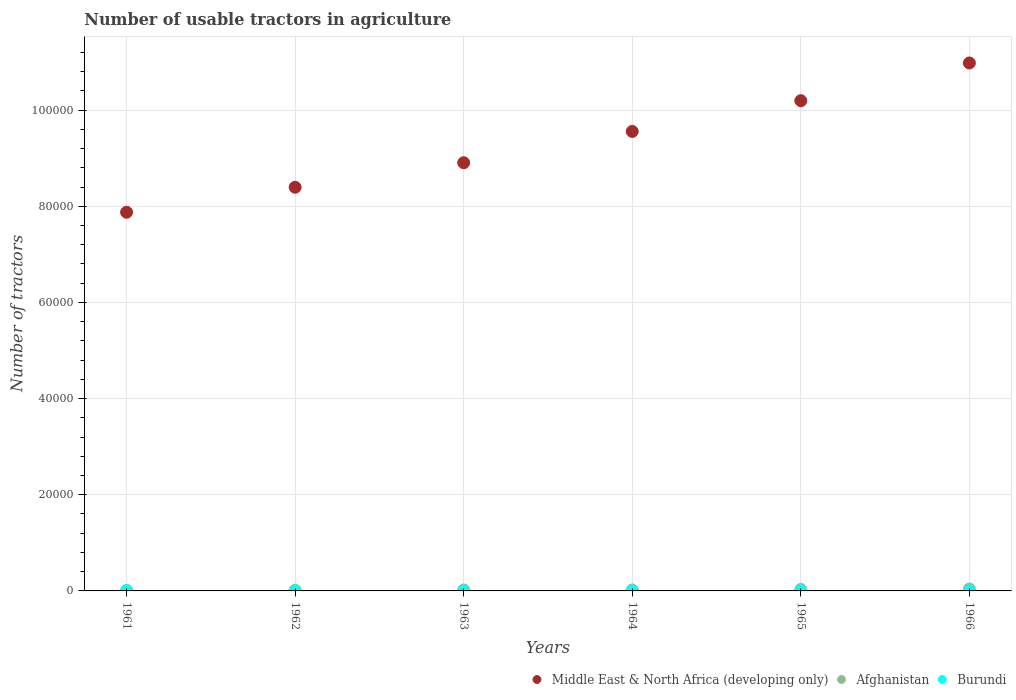What is the number of usable tractors in agriculture in Burundi in 1966?
Provide a succinct answer. 2. Across all years, what is the maximum number of usable tractors in agriculture in Burundi?
Your response must be concise. 2. Across all years, what is the minimum number of usable tractors in agriculture in Afghanistan?
Provide a short and direct response. 120. In which year was the number of usable tractors in agriculture in Burundi maximum?
Provide a short and direct response. 1961. In which year was the number of usable tractors in agriculture in Middle East & North Africa (developing only) minimum?
Your answer should be very brief. 1961. What is the total number of usable tractors in agriculture in Afghanistan in the graph?
Provide a succinct answer. 1370. What is the difference between the number of usable tractors in agriculture in Afghanistan in 1961 and that in 1966?
Provide a short and direct response. -280. What is the difference between the number of usable tractors in agriculture in Burundi in 1961 and the number of usable tractors in agriculture in Afghanistan in 1963?
Keep it short and to the point. -198. What is the average number of usable tractors in agriculture in Afghanistan per year?
Offer a very short reply. 228.33. In the year 1963, what is the difference between the number of usable tractors in agriculture in Middle East & North Africa (developing only) and number of usable tractors in agriculture in Burundi?
Make the answer very short. 8.91e+04. In how many years, is the number of usable tractors in agriculture in Middle East & North Africa (developing only) greater than 88000?
Give a very brief answer. 4. What is the ratio of the number of usable tractors in agriculture in Middle East & North Africa (developing only) in 1961 to that in 1962?
Your answer should be very brief. 0.94. What is the difference between the highest and the lowest number of usable tractors in agriculture in Afghanistan?
Give a very brief answer. 280. Is it the case that in every year, the sum of the number of usable tractors in agriculture in Afghanistan and number of usable tractors in agriculture in Burundi  is greater than the number of usable tractors in agriculture in Middle East & North Africa (developing only)?
Provide a succinct answer. No. Does the graph contain any zero values?
Your answer should be compact. No. Where does the legend appear in the graph?
Make the answer very short. Bottom right. How many legend labels are there?
Ensure brevity in your answer.  3. What is the title of the graph?
Offer a terse response. Number of usable tractors in agriculture. What is the label or title of the X-axis?
Keep it short and to the point. Years. What is the label or title of the Y-axis?
Provide a succinct answer. Number of tractors. What is the Number of tractors of Middle East & North Africa (developing only) in 1961?
Your answer should be very brief. 7.88e+04. What is the Number of tractors in Afghanistan in 1961?
Ensure brevity in your answer.  120. What is the Number of tractors of Middle East & North Africa (developing only) in 1962?
Your answer should be compact. 8.40e+04. What is the Number of tractors of Afghanistan in 1962?
Provide a short and direct response. 150. What is the Number of tractors in Middle East & North Africa (developing only) in 1963?
Keep it short and to the point. 8.91e+04. What is the Number of tractors in Afghanistan in 1963?
Your answer should be very brief. 200. What is the Number of tractors of Middle East & North Africa (developing only) in 1964?
Make the answer very short. 9.56e+04. What is the Number of tractors in Afghanistan in 1964?
Provide a short and direct response. 200. What is the Number of tractors of Middle East & North Africa (developing only) in 1965?
Provide a short and direct response. 1.02e+05. What is the Number of tractors of Afghanistan in 1965?
Provide a short and direct response. 300. What is the Number of tractors in Middle East & North Africa (developing only) in 1966?
Offer a terse response. 1.10e+05. What is the Number of tractors in Afghanistan in 1966?
Provide a short and direct response. 400. What is the Number of tractors in Burundi in 1966?
Offer a terse response. 2. Across all years, what is the maximum Number of tractors of Middle East & North Africa (developing only)?
Provide a short and direct response. 1.10e+05. Across all years, what is the maximum Number of tractors of Afghanistan?
Offer a very short reply. 400. Across all years, what is the minimum Number of tractors in Middle East & North Africa (developing only)?
Provide a succinct answer. 7.88e+04. Across all years, what is the minimum Number of tractors in Afghanistan?
Provide a short and direct response. 120. What is the total Number of tractors in Middle East & North Africa (developing only) in the graph?
Your response must be concise. 5.59e+05. What is the total Number of tractors of Afghanistan in the graph?
Provide a succinct answer. 1370. What is the difference between the Number of tractors of Middle East & North Africa (developing only) in 1961 and that in 1962?
Provide a short and direct response. -5192. What is the difference between the Number of tractors of Afghanistan in 1961 and that in 1962?
Your response must be concise. -30. What is the difference between the Number of tractors of Middle East & North Africa (developing only) in 1961 and that in 1963?
Provide a short and direct response. -1.03e+04. What is the difference between the Number of tractors in Afghanistan in 1961 and that in 1963?
Give a very brief answer. -80. What is the difference between the Number of tractors of Middle East & North Africa (developing only) in 1961 and that in 1964?
Your response must be concise. -1.68e+04. What is the difference between the Number of tractors of Afghanistan in 1961 and that in 1964?
Offer a terse response. -80. What is the difference between the Number of tractors in Burundi in 1961 and that in 1964?
Offer a terse response. 0. What is the difference between the Number of tractors in Middle East & North Africa (developing only) in 1961 and that in 1965?
Offer a very short reply. -2.32e+04. What is the difference between the Number of tractors in Afghanistan in 1961 and that in 1965?
Make the answer very short. -180. What is the difference between the Number of tractors in Burundi in 1961 and that in 1965?
Give a very brief answer. 0. What is the difference between the Number of tractors in Middle East & North Africa (developing only) in 1961 and that in 1966?
Provide a short and direct response. -3.10e+04. What is the difference between the Number of tractors of Afghanistan in 1961 and that in 1966?
Offer a terse response. -280. What is the difference between the Number of tractors in Middle East & North Africa (developing only) in 1962 and that in 1963?
Provide a short and direct response. -5107. What is the difference between the Number of tractors of Middle East & North Africa (developing only) in 1962 and that in 1964?
Your answer should be very brief. -1.16e+04. What is the difference between the Number of tractors of Afghanistan in 1962 and that in 1964?
Make the answer very short. -50. What is the difference between the Number of tractors in Middle East & North Africa (developing only) in 1962 and that in 1965?
Your response must be concise. -1.80e+04. What is the difference between the Number of tractors in Afghanistan in 1962 and that in 1965?
Your answer should be very brief. -150. What is the difference between the Number of tractors in Burundi in 1962 and that in 1965?
Offer a very short reply. 0. What is the difference between the Number of tractors in Middle East & North Africa (developing only) in 1962 and that in 1966?
Your response must be concise. -2.59e+04. What is the difference between the Number of tractors in Afghanistan in 1962 and that in 1966?
Give a very brief answer. -250. What is the difference between the Number of tractors of Burundi in 1962 and that in 1966?
Keep it short and to the point. 0. What is the difference between the Number of tractors of Middle East & North Africa (developing only) in 1963 and that in 1964?
Offer a terse response. -6506. What is the difference between the Number of tractors in Burundi in 1963 and that in 1964?
Provide a short and direct response. 0. What is the difference between the Number of tractors of Middle East & North Africa (developing only) in 1963 and that in 1965?
Keep it short and to the point. -1.29e+04. What is the difference between the Number of tractors of Afghanistan in 1963 and that in 1965?
Your answer should be compact. -100. What is the difference between the Number of tractors of Burundi in 1963 and that in 1965?
Your answer should be very brief. 0. What is the difference between the Number of tractors in Middle East & North Africa (developing only) in 1963 and that in 1966?
Your answer should be compact. -2.07e+04. What is the difference between the Number of tractors of Afghanistan in 1963 and that in 1966?
Your answer should be very brief. -200. What is the difference between the Number of tractors of Burundi in 1963 and that in 1966?
Your answer should be compact. 0. What is the difference between the Number of tractors in Middle East & North Africa (developing only) in 1964 and that in 1965?
Your answer should be compact. -6395. What is the difference between the Number of tractors in Afghanistan in 1964 and that in 1965?
Offer a terse response. -100. What is the difference between the Number of tractors in Middle East & North Africa (developing only) in 1964 and that in 1966?
Your answer should be compact. -1.42e+04. What is the difference between the Number of tractors of Afghanistan in 1964 and that in 1966?
Offer a terse response. -200. What is the difference between the Number of tractors in Middle East & North Africa (developing only) in 1965 and that in 1966?
Keep it short and to the point. -7846. What is the difference between the Number of tractors in Afghanistan in 1965 and that in 1966?
Your answer should be very brief. -100. What is the difference between the Number of tractors of Middle East & North Africa (developing only) in 1961 and the Number of tractors of Afghanistan in 1962?
Provide a short and direct response. 7.86e+04. What is the difference between the Number of tractors of Middle East & North Africa (developing only) in 1961 and the Number of tractors of Burundi in 1962?
Your answer should be very brief. 7.88e+04. What is the difference between the Number of tractors in Afghanistan in 1961 and the Number of tractors in Burundi in 1962?
Your answer should be very brief. 118. What is the difference between the Number of tractors in Middle East & North Africa (developing only) in 1961 and the Number of tractors in Afghanistan in 1963?
Make the answer very short. 7.86e+04. What is the difference between the Number of tractors of Middle East & North Africa (developing only) in 1961 and the Number of tractors of Burundi in 1963?
Offer a terse response. 7.88e+04. What is the difference between the Number of tractors of Afghanistan in 1961 and the Number of tractors of Burundi in 1963?
Ensure brevity in your answer.  118. What is the difference between the Number of tractors in Middle East & North Africa (developing only) in 1961 and the Number of tractors in Afghanistan in 1964?
Offer a very short reply. 7.86e+04. What is the difference between the Number of tractors in Middle East & North Africa (developing only) in 1961 and the Number of tractors in Burundi in 1964?
Make the answer very short. 7.88e+04. What is the difference between the Number of tractors in Afghanistan in 1961 and the Number of tractors in Burundi in 1964?
Offer a very short reply. 118. What is the difference between the Number of tractors in Middle East & North Africa (developing only) in 1961 and the Number of tractors in Afghanistan in 1965?
Ensure brevity in your answer.  7.85e+04. What is the difference between the Number of tractors in Middle East & North Africa (developing only) in 1961 and the Number of tractors in Burundi in 1965?
Provide a short and direct response. 7.88e+04. What is the difference between the Number of tractors in Afghanistan in 1961 and the Number of tractors in Burundi in 1965?
Give a very brief answer. 118. What is the difference between the Number of tractors in Middle East & North Africa (developing only) in 1961 and the Number of tractors in Afghanistan in 1966?
Keep it short and to the point. 7.84e+04. What is the difference between the Number of tractors in Middle East & North Africa (developing only) in 1961 and the Number of tractors in Burundi in 1966?
Provide a succinct answer. 7.88e+04. What is the difference between the Number of tractors in Afghanistan in 1961 and the Number of tractors in Burundi in 1966?
Provide a succinct answer. 118. What is the difference between the Number of tractors in Middle East & North Africa (developing only) in 1962 and the Number of tractors in Afghanistan in 1963?
Offer a very short reply. 8.38e+04. What is the difference between the Number of tractors in Middle East & North Africa (developing only) in 1962 and the Number of tractors in Burundi in 1963?
Your answer should be compact. 8.39e+04. What is the difference between the Number of tractors of Afghanistan in 1962 and the Number of tractors of Burundi in 1963?
Your response must be concise. 148. What is the difference between the Number of tractors in Middle East & North Africa (developing only) in 1962 and the Number of tractors in Afghanistan in 1964?
Offer a very short reply. 8.38e+04. What is the difference between the Number of tractors in Middle East & North Africa (developing only) in 1962 and the Number of tractors in Burundi in 1964?
Your answer should be compact. 8.39e+04. What is the difference between the Number of tractors in Afghanistan in 1962 and the Number of tractors in Burundi in 1964?
Give a very brief answer. 148. What is the difference between the Number of tractors in Middle East & North Africa (developing only) in 1962 and the Number of tractors in Afghanistan in 1965?
Ensure brevity in your answer.  8.36e+04. What is the difference between the Number of tractors in Middle East & North Africa (developing only) in 1962 and the Number of tractors in Burundi in 1965?
Your response must be concise. 8.39e+04. What is the difference between the Number of tractors in Afghanistan in 1962 and the Number of tractors in Burundi in 1965?
Provide a short and direct response. 148. What is the difference between the Number of tractors in Middle East & North Africa (developing only) in 1962 and the Number of tractors in Afghanistan in 1966?
Keep it short and to the point. 8.36e+04. What is the difference between the Number of tractors of Middle East & North Africa (developing only) in 1962 and the Number of tractors of Burundi in 1966?
Offer a terse response. 8.39e+04. What is the difference between the Number of tractors in Afghanistan in 1962 and the Number of tractors in Burundi in 1966?
Make the answer very short. 148. What is the difference between the Number of tractors of Middle East & North Africa (developing only) in 1963 and the Number of tractors of Afghanistan in 1964?
Give a very brief answer. 8.89e+04. What is the difference between the Number of tractors in Middle East & North Africa (developing only) in 1963 and the Number of tractors in Burundi in 1964?
Ensure brevity in your answer.  8.91e+04. What is the difference between the Number of tractors of Afghanistan in 1963 and the Number of tractors of Burundi in 1964?
Your answer should be very brief. 198. What is the difference between the Number of tractors in Middle East & North Africa (developing only) in 1963 and the Number of tractors in Afghanistan in 1965?
Your answer should be compact. 8.88e+04. What is the difference between the Number of tractors in Middle East & North Africa (developing only) in 1963 and the Number of tractors in Burundi in 1965?
Provide a short and direct response. 8.91e+04. What is the difference between the Number of tractors of Afghanistan in 1963 and the Number of tractors of Burundi in 1965?
Offer a terse response. 198. What is the difference between the Number of tractors of Middle East & North Africa (developing only) in 1963 and the Number of tractors of Afghanistan in 1966?
Make the answer very short. 8.87e+04. What is the difference between the Number of tractors of Middle East & North Africa (developing only) in 1963 and the Number of tractors of Burundi in 1966?
Your response must be concise. 8.91e+04. What is the difference between the Number of tractors in Afghanistan in 1963 and the Number of tractors in Burundi in 1966?
Provide a succinct answer. 198. What is the difference between the Number of tractors in Middle East & North Africa (developing only) in 1964 and the Number of tractors in Afghanistan in 1965?
Your answer should be very brief. 9.53e+04. What is the difference between the Number of tractors in Middle East & North Africa (developing only) in 1964 and the Number of tractors in Burundi in 1965?
Provide a short and direct response. 9.56e+04. What is the difference between the Number of tractors in Afghanistan in 1964 and the Number of tractors in Burundi in 1965?
Provide a succinct answer. 198. What is the difference between the Number of tractors in Middle East & North Africa (developing only) in 1964 and the Number of tractors in Afghanistan in 1966?
Provide a succinct answer. 9.52e+04. What is the difference between the Number of tractors in Middle East & North Africa (developing only) in 1964 and the Number of tractors in Burundi in 1966?
Offer a very short reply. 9.56e+04. What is the difference between the Number of tractors of Afghanistan in 1964 and the Number of tractors of Burundi in 1966?
Give a very brief answer. 198. What is the difference between the Number of tractors of Middle East & North Africa (developing only) in 1965 and the Number of tractors of Afghanistan in 1966?
Offer a very short reply. 1.02e+05. What is the difference between the Number of tractors in Middle East & North Africa (developing only) in 1965 and the Number of tractors in Burundi in 1966?
Provide a succinct answer. 1.02e+05. What is the difference between the Number of tractors of Afghanistan in 1965 and the Number of tractors of Burundi in 1966?
Provide a short and direct response. 298. What is the average Number of tractors of Middle East & North Africa (developing only) per year?
Ensure brevity in your answer.  9.32e+04. What is the average Number of tractors of Afghanistan per year?
Make the answer very short. 228.33. What is the average Number of tractors of Burundi per year?
Your answer should be compact. 2. In the year 1961, what is the difference between the Number of tractors of Middle East & North Africa (developing only) and Number of tractors of Afghanistan?
Provide a succinct answer. 7.86e+04. In the year 1961, what is the difference between the Number of tractors in Middle East & North Africa (developing only) and Number of tractors in Burundi?
Give a very brief answer. 7.88e+04. In the year 1961, what is the difference between the Number of tractors in Afghanistan and Number of tractors in Burundi?
Offer a very short reply. 118. In the year 1962, what is the difference between the Number of tractors of Middle East & North Africa (developing only) and Number of tractors of Afghanistan?
Make the answer very short. 8.38e+04. In the year 1962, what is the difference between the Number of tractors in Middle East & North Africa (developing only) and Number of tractors in Burundi?
Your answer should be very brief. 8.39e+04. In the year 1962, what is the difference between the Number of tractors in Afghanistan and Number of tractors in Burundi?
Make the answer very short. 148. In the year 1963, what is the difference between the Number of tractors of Middle East & North Africa (developing only) and Number of tractors of Afghanistan?
Provide a short and direct response. 8.89e+04. In the year 1963, what is the difference between the Number of tractors of Middle East & North Africa (developing only) and Number of tractors of Burundi?
Your answer should be very brief. 8.91e+04. In the year 1963, what is the difference between the Number of tractors in Afghanistan and Number of tractors in Burundi?
Offer a very short reply. 198. In the year 1964, what is the difference between the Number of tractors in Middle East & North Africa (developing only) and Number of tractors in Afghanistan?
Provide a succinct answer. 9.54e+04. In the year 1964, what is the difference between the Number of tractors in Middle East & North Africa (developing only) and Number of tractors in Burundi?
Your response must be concise. 9.56e+04. In the year 1964, what is the difference between the Number of tractors in Afghanistan and Number of tractors in Burundi?
Keep it short and to the point. 198. In the year 1965, what is the difference between the Number of tractors in Middle East & North Africa (developing only) and Number of tractors in Afghanistan?
Your answer should be very brief. 1.02e+05. In the year 1965, what is the difference between the Number of tractors in Middle East & North Africa (developing only) and Number of tractors in Burundi?
Your answer should be very brief. 1.02e+05. In the year 1965, what is the difference between the Number of tractors of Afghanistan and Number of tractors of Burundi?
Provide a succinct answer. 298. In the year 1966, what is the difference between the Number of tractors in Middle East & North Africa (developing only) and Number of tractors in Afghanistan?
Your answer should be compact. 1.09e+05. In the year 1966, what is the difference between the Number of tractors in Middle East & North Africa (developing only) and Number of tractors in Burundi?
Offer a terse response. 1.10e+05. In the year 1966, what is the difference between the Number of tractors of Afghanistan and Number of tractors of Burundi?
Make the answer very short. 398. What is the ratio of the Number of tractors of Middle East & North Africa (developing only) in 1961 to that in 1962?
Provide a short and direct response. 0.94. What is the ratio of the Number of tractors in Afghanistan in 1961 to that in 1962?
Provide a short and direct response. 0.8. What is the ratio of the Number of tractors of Middle East & North Africa (developing only) in 1961 to that in 1963?
Your answer should be compact. 0.88. What is the ratio of the Number of tractors in Burundi in 1961 to that in 1963?
Provide a succinct answer. 1. What is the ratio of the Number of tractors in Middle East & North Africa (developing only) in 1961 to that in 1964?
Give a very brief answer. 0.82. What is the ratio of the Number of tractors of Middle East & North Africa (developing only) in 1961 to that in 1965?
Make the answer very short. 0.77. What is the ratio of the Number of tractors in Afghanistan in 1961 to that in 1965?
Keep it short and to the point. 0.4. What is the ratio of the Number of tractors in Burundi in 1961 to that in 1965?
Provide a succinct answer. 1. What is the ratio of the Number of tractors of Middle East & North Africa (developing only) in 1961 to that in 1966?
Provide a succinct answer. 0.72. What is the ratio of the Number of tractors in Middle East & North Africa (developing only) in 1962 to that in 1963?
Keep it short and to the point. 0.94. What is the ratio of the Number of tractors of Afghanistan in 1962 to that in 1963?
Provide a short and direct response. 0.75. What is the ratio of the Number of tractors of Burundi in 1962 to that in 1963?
Provide a succinct answer. 1. What is the ratio of the Number of tractors of Middle East & North Africa (developing only) in 1962 to that in 1964?
Give a very brief answer. 0.88. What is the ratio of the Number of tractors in Afghanistan in 1962 to that in 1964?
Provide a succinct answer. 0.75. What is the ratio of the Number of tractors in Burundi in 1962 to that in 1964?
Provide a short and direct response. 1. What is the ratio of the Number of tractors in Middle East & North Africa (developing only) in 1962 to that in 1965?
Offer a terse response. 0.82. What is the ratio of the Number of tractors in Afghanistan in 1962 to that in 1965?
Make the answer very short. 0.5. What is the ratio of the Number of tractors in Burundi in 1962 to that in 1965?
Make the answer very short. 1. What is the ratio of the Number of tractors of Middle East & North Africa (developing only) in 1962 to that in 1966?
Provide a succinct answer. 0.76. What is the ratio of the Number of tractors in Afghanistan in 1962 to that in 1966?
Your response must be concise. 0.38. What is the ratio of the Number of tractors of Middle East & North Africa (developing only) in 1963 to that in 1964?
Offer a very short reply. 0.93. What is the ratio of the Number of tractors in Burundi in 1963 to that in 1964?
Provide a succinct answer. 1. What is the ratio of the Number of tractors of Middle East & North Africa (developing only) in 1963 to that in 1965?
Your response must be concise. 0.87. What is the ratio of the Number of tractors in Middle East & North Africa (developing only) in 1963 to that in 1966?
Your answer should be very brief. 0.81. What is the ratio of the Number of tractors in Afghanistan in 1963 to that in 1966?
Provide a succinct answer. 0.5. What is the ratio of the Number of tractors in Burundi in 1963 to that in 1966?
Offer a very short reply. 1. What is the ratio of the Number of tractors in Middle East & North Africa (developing only) in 1964 to that in 1965?
Your answer should be very brief. 0.94. What is the ratio of the Number of tractors in Middle East & North Africa (developing only) in 1964 to that in 1966?
Make the answer very short. 0.87. What is the ratio of the Number of tractors in Burundi in 1964 to that in 1966?
Your response must be concise. 1. What is the ratio of the Number of tractors in Middle East & North Africa (developing only) in 1965 to that in 1966?
Your response must be concise. 0.93. What is the ratio of the Number of tractors in Afghanistan in 1965 to that in 1966?
Your answer should be very brief. 0.75. What is the difference between the highest and the second highest Number of tractors of Middle East & North Africa (developing only)?
Your answer should be very brief. 7846. What is the difference between the highest and the lowest Number of tractors of Middle East & North Africa (developing only)?
Provide a succinct answer. 3.10e+04. What is the difference between the highest and the lowest Number of tractors in Afghanistan?
Make the answer very short. 280. 